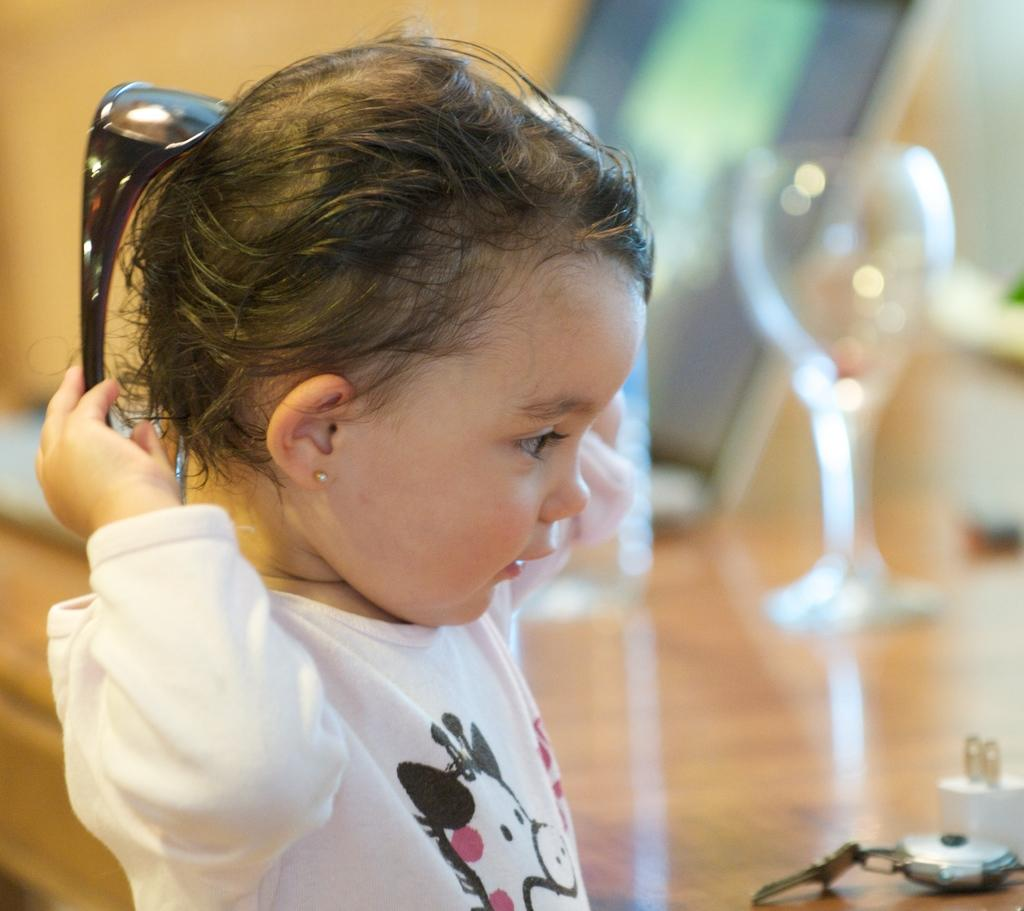What is the main subject of the image? The main subject of the image is a kid. What is the kid holding in the image? The kid is holding spectacles in the image. What else can be seen in the image besides the kid and the spectacles? There is a glass and a key chain in the image. Are there any other objects visible on the surface in the image? Yes, there are other objects on the surface in the image. What type of cake is being served at the point in the image? There is no cake or point visible in the image; it only features a kid holding spectacles, a glass, a key chain, and other unspecified objects on the surface. 